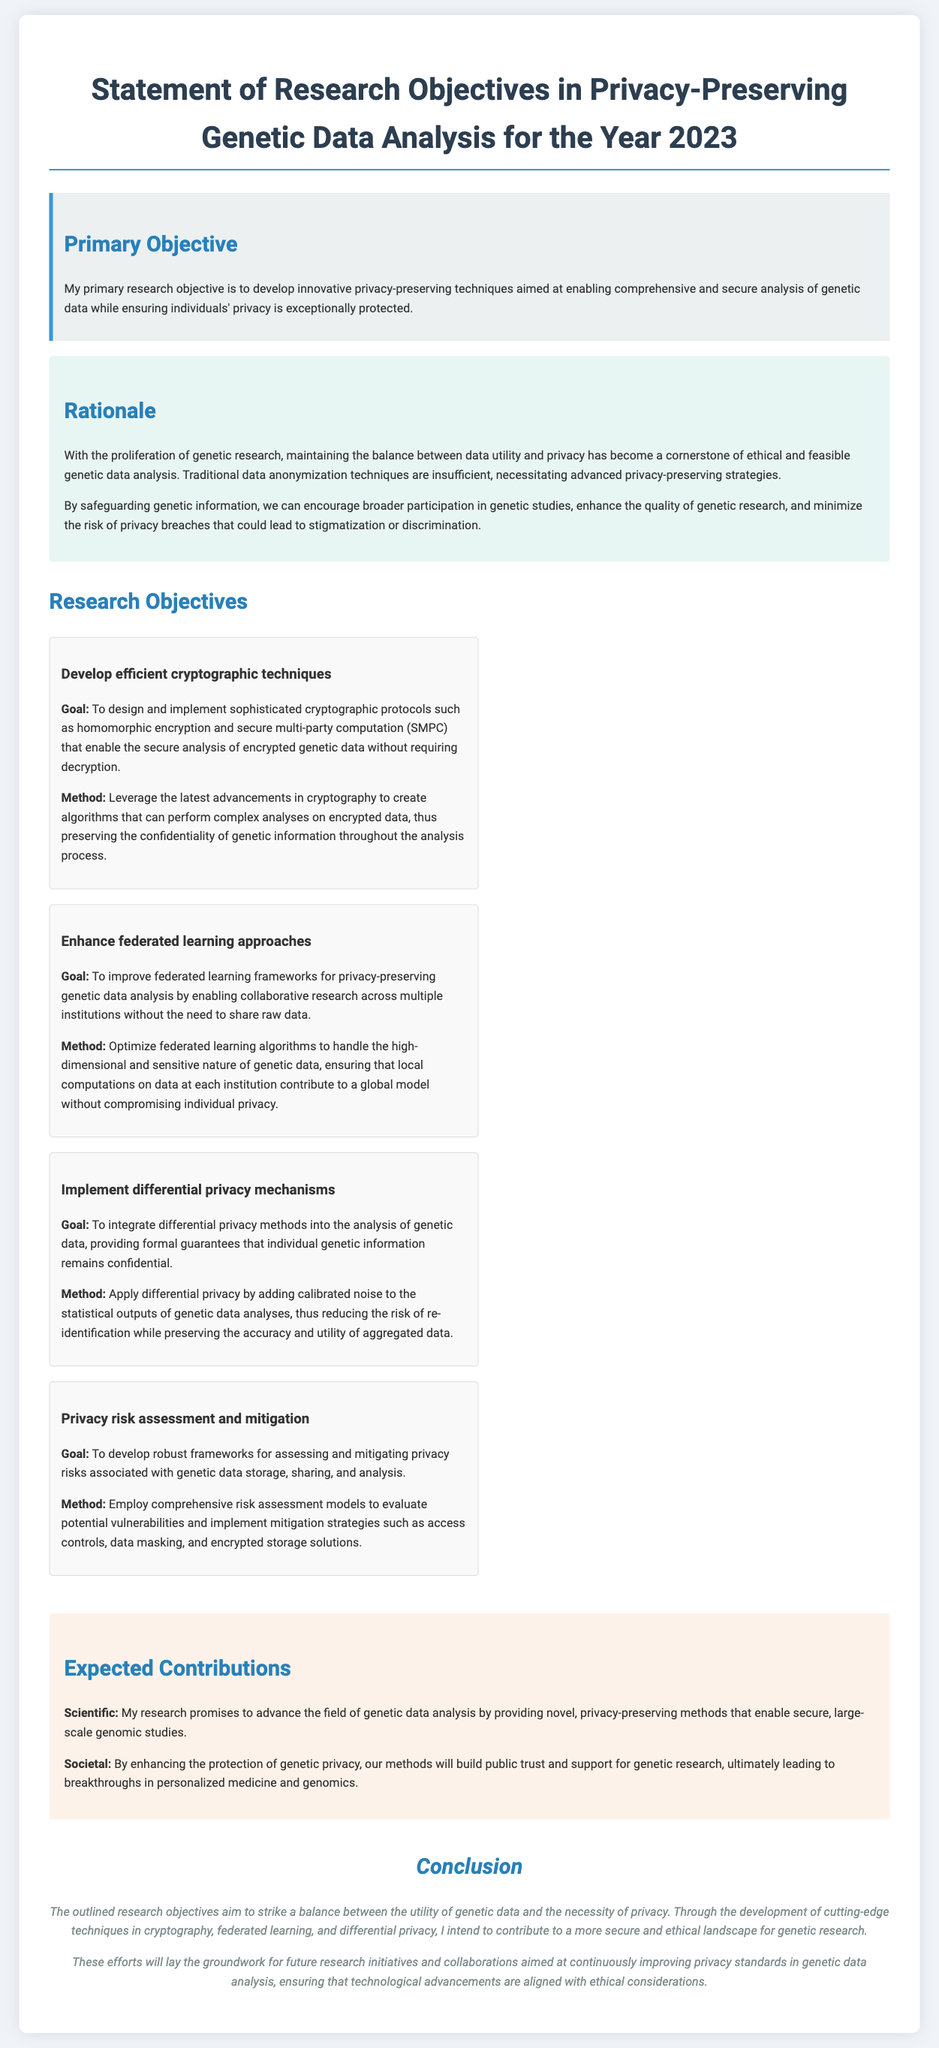What is the primary research objective stated? The primary research objective is the main focus of the document, highlighting its significance in privacy-preserving techniques for genetic data analysis.
Answer: develop innovative privacy-preserving techniques What are the two types of cryptographic techniques mentioned? The document lists specific cryptographic techniques under research objectives, providing insight into the proposed methods for analysis of genetic data.
Answer: homomorphic encryption and secure multi-party computation How many research objectives are outlined in the document? This question asks for a specific numerical count of the objectives laid out in the research declaration.
Answer: four What is the main benefit of integrating differential privacy methods? Understanding this benefit highlights the intention behind the objective, indicating the aim of protecting individual information in genetic data analysis.
Answer: confidentiality What challenge do traditional data anonymization techniques face? This question seeks to extract underlying challenges presented, reflecting on the need for advanced strategies in genetic data analysis.
Answer: insufficient Which framework is being improved for privacy-preserving genetic data analysis? The document identifies a specific framework that is being enhanced for better data privacy solutions, showing the collaborative aspect of the research.
Answer: federated learning What is the expected scientific contribution of this research? This question aims to ascertain the scientific impact anticipated from the research study, pulling from the contributions section.
Answer: novel, privacy-preserving methods What is the conclusion about the necessity of privacy? This question focuses on the reasoning behind the conclusion, reflecting on the importance of ethical standards in ongoing research.
Answer: utility of genetic data and necessity of privacy 